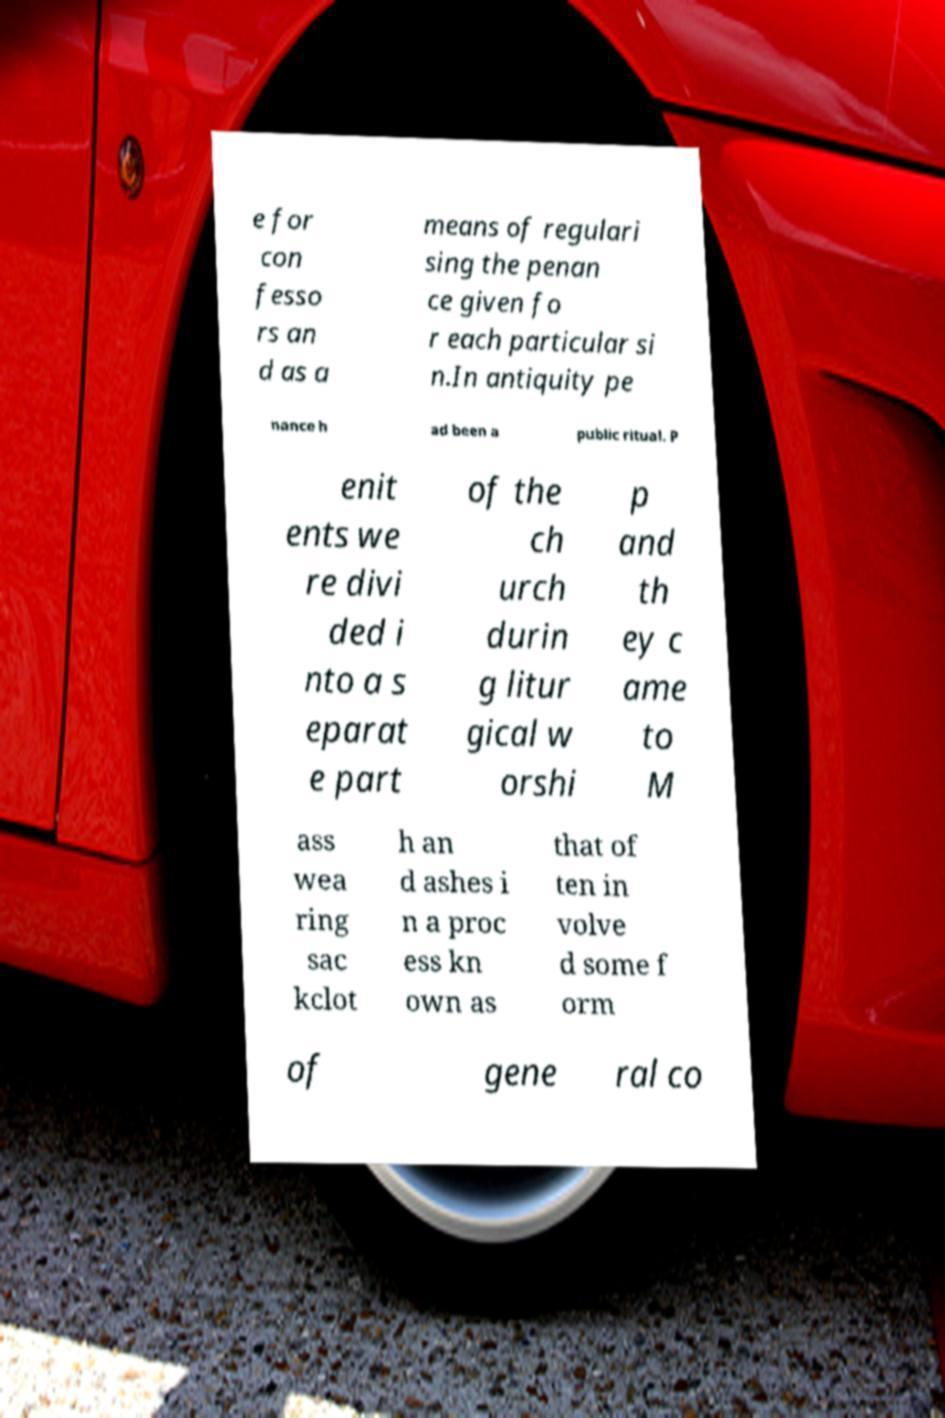For documentation purposes, I need the text within this image transcribed. Could you provide that? e for con fesso rs an d as a means of regulari sing the penan ce given fo r each particular si n.In antiquity pe nance h ad been a public ritual. P enit ents we re divi ded i nto a s eparat e part of the ch urch durin g litur gical w orshi p and th ey c ame to M ass wea ring sac kclot h an d ashes i n a proc ess kn own as that of ten in volve d some f orm of gene ral co 